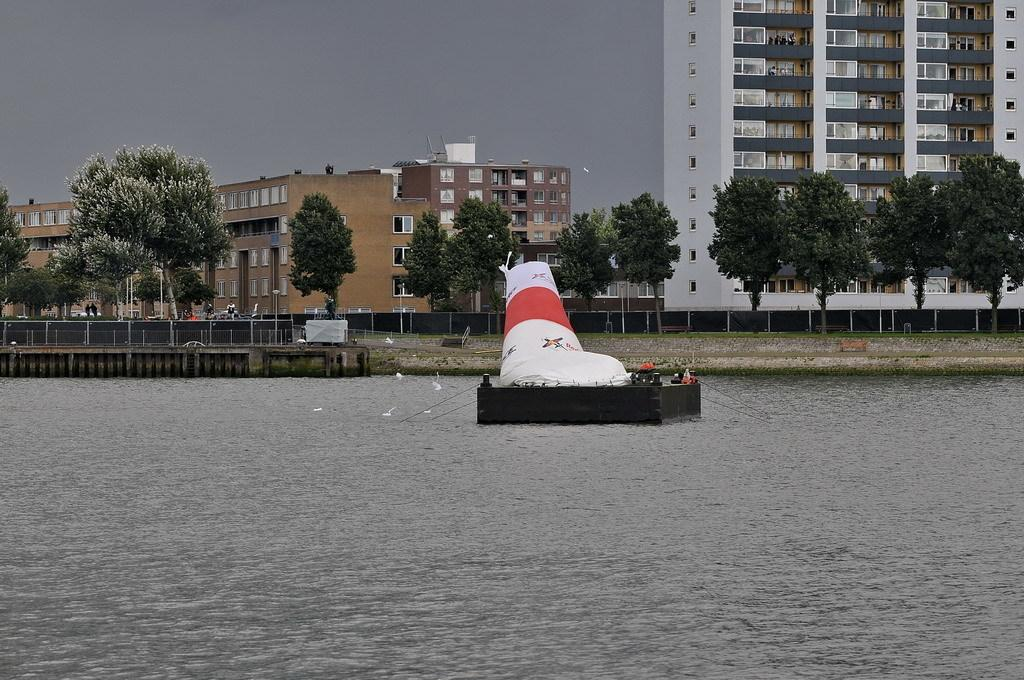What is the main subject in the center of the image? There is a boat in the center of the image. Where is the boat located? The boat is on the water. What other living creatures can be seen in the image? There are birds in the image. What is on the left side of the image? There is a fence on the left side of the image. What can be seen in the background of the image? There are trees, buildings, and the sky visible in the background of the image. What type of pest is causing problems for the boat in the image? There is no pest causing problems for the boat in the image. The boat is on the water, and there are no signs of any pests or issues related to them. 